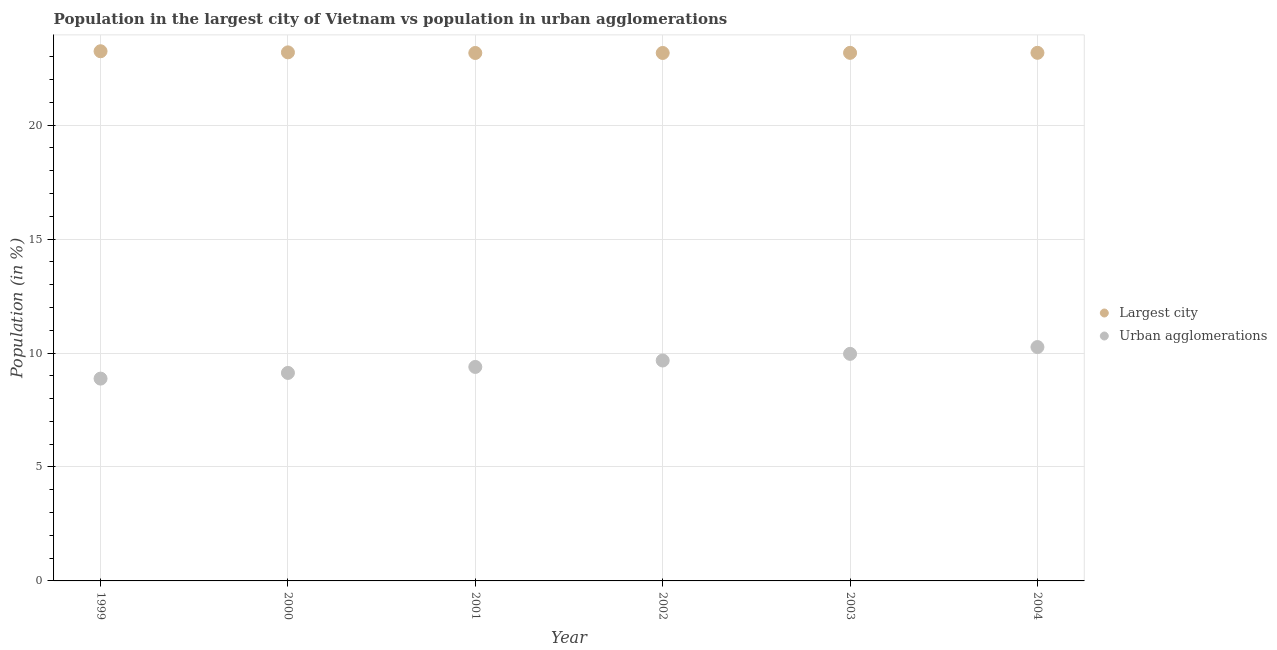How many different coloured dotlines are there?
Make the answer very short. 2. Is the number of dotlines equal to the number of legend labels?
Offer a terse response. Yes. What is the population in the largest city in 2001?
Make the answer very short. 23.17. Across all years, what is the maximum population in the largest city?
Give a very brief answer. 23.25. Across all years, what is the minimum population in urban agglomerations?
Your answer should be compact. 8.88. In which year was the population in the largest city maximum?
Make the answer very short. 1999. In which year was the population in urban agglomerations minimum?
Make the answer very short. 1999. What is the total population in urban agglomerations in the graph?
Ensure brevity in your answer.  57.3. What is the difference between the population in the largest city in 2003 and that in 2004?
Give a very brief answer. -0. What is the difference between the population in the largest city in 2001 and the population in urban agglomerations in 2000?
Keep it short and to the point. 14.04. What is the average population in urban agglomerations per year?
Ensure brevity in your answer.  9.55. In the year 1999, what is the difference between the population in the largest city and population in urban agglomerations?
Give a very brief answer. 14.37. What is the ratio of the population in urban agglomerations in 2000 to that in 2004?
Provide a short and direct response. 0.89. Is the population in urban agglomerations in 1999 less than that in 2004?
Make the answer very short. Yes. What is the difference between the highest and the second highest population in the largest city?
Your response must be concise. 0.05. What is the difference between the highest and the lowest population in urban agglomerations?
Your answer should be compact. 1.38. In how many years, is the population in the largest city greater than the average population in the largest city taken over all years?
Offer a very short reply. 2. What is the difference between two consecutive major ticks on the Y-axis?
Offer a terse response. 5. Are the values on the major ticks of Y-axis written in scientific E-notation?
Make the answer very short. No. Does the graph contain any zero values?
Your answer should be compact. No. How are the legend labels stacked?
Give a very brief answer. Vertical. What is the title of the graph?
Your answer should be compact. Population in the largest city of Vietnam vs population in urban agglomerations. Does "Frequency of shipment arrival" appear as one of the legend labels in the graph?
Keep it short and to the point. No. What is the label or title of the X-axis?
Make the answer very short. Year. What is the Population (in %) in Largest city in 1999?
Keep it short and to the point. 23.25. What is the Population (in %) of Urban agglomerations in 1999?
Your response must be concise. 8.88. What is the Population (in %) of Largest city in 2000?
Make the answer very short. 23.2. What is the Population (in %) of Urban agglomerations in 2000?
Make the answer very short. 9.13. What is the Population (in %) of Largest city in 2001?
Your answer should be very brief. 23.17. What is the Population (in %) in Urban agglomerations in 2001?
Your response must be concise. 9.39. What is the Population (in %) in Largest city in 2002?
Offer a very short reply. 23.17. What is the Population (in %) of Urban agglomerations in 2002?
Your answer should be very brief. 9.67. What is the Population (in %) in Largest city in 2003?
Your response must be concise. 23.18. What is the Population (in %) of Urban agglomerations in 2003?
Provide a short and direct response. 9.97. What is the Population (in %) of Largest city in 2004?
Ensure brevity in your answer.  23.18. What is the Population (in %) in Urban agglomerations in 2004?
Your answer should be very brief. 10.26. Across all years, what is the maximum Population (in %) in Largest city?
Provide a succinct answer. 23.25. Across all years, what is the maximum Population (in %) in Urban agglomerations?
Your answer should be compact. 10.26. Across all years, what is the minimum Population (in %) of Largest city?
Offer a terse response. 23.17. Across all years, what is the minimum Population (in %) in Urban agglomerations?
Give a very brief answer. 8.88. What is the total Population (in %) in Largest city in the graph?
Make the answer very short. 139.14. What is the total Population (in %) of Urban agglomerations in the graph?
Offer a very short reply. 57.3. What is the difference between the Population (in %) in Largest city in 1999 and that in 2000?
Ensure brevity in your answer.  0.05. What is the difference between the Population (in %) of Urban agglomerations in 1999 and that in 2000?
Your answer should be compact. -0.25. What is the difference between the Population (in %) in Largest city in 1999 and that in 2001?
Keep it short and to the point. 0.08. What is the difference between the Population (in %) in Urban agglomerations in 1999 and that in 2001?
Provide a succinct answer. -0.51. What is the difference between the Population (in %) in Largest city in 1999 and that in 2002?
Provide a short and direct response. 0.08. What is the difference between the Population (in %) in Urban agglomerations in 1999 and that in 2002?
Keep it short and to the point. -0.79. What is the difference between the Population (in %) of Largest city in 1999 and that in 2003?
Your answer should be very brief. 0.07. What is the difference between the Population (in %) in Urban agglomerations in 1999 and that in 2003?
Offer a terse response. -1.09. What is the difference between the Population (in %) in Largest city in 1999 and that in 2004?
Offer a very short reply. 0.07. What is the difference between the Population (in %) in Urban agglomerations in 1999 and that in 2004?
Keep it short and to the point. -1.38. What is the difference between the Population (in %) in Largest city in 2000 and that in 2001?
Ensure brevity in your answer.  0.03. What is the difference between the Population (in %) in Urban agglomerations in 2000 and that in 2001?
Your response must be concise. -0.26. What is the difference between the Population (in %) of Largest city in 2000 and that in 2002?
Offer a terse response. 0.03. What is the difference between the Population (in %) in Urban agglomerations in 2000 and that in 2002?
Your answer should be compact. -0.55. What is the difference between the Population (in %) in Largest city in 2000 and that in 2003?
Make the answer very short. 0.02. What is the difference between the Population (in %) in Urban agglomerations in 2000 and that in 2003?
Make the answer very short. -0.84. What is the difference between the Population (in %) in Largest city in 2000 and that in 2004?
Make the answer very short. 0.02. What is the difference between the Population (in %) in Urban agglomerations in 2000 and that in 2004?
Your response must be concise. -1.14. What is the difference between the Population (in %) in Largest city in 2001 and that in 2002?
Provide a short and direct response. -0. What is the difference between the Population (in %) in Urban agglomerations in 2001 and that in 2002?
Provide a short and direct response. -0.28. What is the difference between the Population (in %) in Largest city in 2001 and that in 2003?
Offer a terse response. -0.01. What is the difference between the Population (in %) in Urban agglomerations in 2001 and that in 2003?
Your answer should be compact. -0.57. What is the difference between the Population (in %) in Largest city in 2001 and that in 2004?
Keep it short and to the point. -0.01. What is the difference between the Population (in %) in Urban agglomerations in 2001 and that in 2004?
Provide a succinct answer. -0.87. What is the difference between the Population (in %) in Largest city in 2002 and that in 2003?
Give a very brief answer. -0.01. What is the difference between the Population (in %) in Urban agglomerations in 2002 and that in 2003?
Your answer should be compact. -0.29. What is the difference between the Population (in %) in Largest city in 2002 and that in 2004?
Offer a terse response. -0.01. What is the difference between the Population (in %) in Urban agglomerations in 2002 and that in 2004?
Your answer should be very brief. -0.59. What is the difference between the Population (in %) in Largest city in 2003 and that in 2004?
Provide a succinct answer. -0. What is the difference between the Population (in %) in Urban agglomerations in 2003 and that in 2004?
Keep it short and to the point. -0.3. What is the difference between the Population (in %) in Largest city in 1999 and the Population (in %) in Urban agglomerations in 2000?
Your response must be concise. 14.12. What is the difference between the Population (in %) of Largest city in 1999 and the Population (in %) of Urban agglomerations in 2001?
Provide a succinct answer. 13.86. What is the difference between the Population (in %) of Largest city in 1999 and the Population (in %) of Urban agglomerations in 2002?
Make the answer very short. 13.57. What is the difference between the Population (in %) in Largest city in 1999 and the Population (in %) in Urban agglomerations in 2003?
Make the answer very short. 13.28. What is the difference between the Population (in %) of Largest city in 1999 and the Population (in %) of Urban agglomerations in 2004?
Your answer should be compact. 12.98. What is the difference between the Population (in %) in Largest city in 2000 and the Population (in %) in Urban agglomerations in 2001?
Offer a terse response. 13.81. What is the difference between the Population (in %) in Largest city in 2000 and the Population (in %) in Urban agglomerations in 2002?
Give a very brief answer. 13.52. What is the difference between the Population (in %) in Largest city in 2000 and the Population (in %) in Urban agglomerations in 2003?
Provide a succinct answer. 13.23. What is the difference between the Population (in %) in Largest city in 2000 and the Population (in %) in Urban agglomerations in 2004?
Your answer should be compact. 12.93. What is the difference between the Population (in %) in Largest city in 2001 and the Population (in %) in Urban agglomerations in 2002?
Offer a terse response. 13.5. What is the difference between the Population (in %) in Largest city in 2001 and the Population (in %) in Urban agglomerations in 2003?
Provide a succinct answer. 13.2. What is the difference between the Population (in %) of Largest city in 2001 and the Population (in %) of Urban agglomerations in 2004?
Provide a short and direct response. 12.91. What is the difference between the Population (in %) of Largest city in 2002 and the Population (in %) of Urban agglomerations in 2003?
Provide a short and direct response. 13.21. What is the difference between the Population (in %) of Largest city in 2002 and the Population (in %) of Urban agglomerations in 2004?
Give a very brief answer. 12.91. What is the difference between the Population (in %) in Largest city in 2003 and the Population (in %) in Urban agglomerations in 2004?
Give a very brief answer. 12.91. What is the average Population (in %) in Largest city per year?
Ensure brevity in your answer.  23.19. What is the average Population (in %) in Urban agglomerations per year?
Offer a very short reply. 9.55. In the year 1999, what is the difference between the Population (in %) in Largest city and Population (in %) in Urban agglomerations?
Your answer should be very brief. 14.37. In the year 2000, what is the difference between the Population (in %) of Largest city and Population (in %) of Urban agglomerations?
Keep it short and to the point. 14.07. In the year 2001, what is the difference between the Population (in %) of Largest city and Population (in %) of Urban agglomerations?
Ensure brevity in your answer.  13.78. In the year 2002, what is the difference between the Population (in %) in Largest city and Population (in %) in Urban agglomerations?
Give a very brief answer. 13.5. In the year 2003, what is the difference between the Population (in %) in Largest city and Population (in %) in Urban agglomerations?
Give a very brief answer. 13.21. In the year 2004, what is the difference between the Population (in %) of Largest city and Population (in %) of Urban agglomerations?
Your answer should be very brief. 12.91. What is the ratio of the Population (in %) of Largest city in 1999 to that in 2000?
Provide a succinct answer. 1. What is the ratio of the Population (in %) of Urban agglomerations in 1999 to that in 2000?
Your response must be concise. 0.97. What is the ratio of the Population (in %) of Largest city in 1999 to that in 2001?
Provide a succinct answer. 1. What is the ratio of the Population (in %) of Urban agglomerations in 1999 to that in 2001?
Give a very brief answer. 0.95. What is the ratio of the Population (in %) of Urban agglomerations in 1999 to that in 2002?
Give a very brief answer. 0.92. What is the ratio of the Population (in %) of Largest city in 1999 to that in 2003?
Ensure brevity in your answer.  1. What is the ratio of the Population (in %) in Urban agglomerations in 1999 to that in 2003?
Ensure brevity in your answer.  0.89. What is the ratio of the Population (in %) in Urban agglomerations in 1999 to that in 2004?
Make the answer very short. 0.87. What is the ratio of the Population (in %) in Urban agglomerations in 2000 to that in 2001?
Give a very brief answer. 0.97. What is the ratio of the Population (in %) of Largest city in 2000 to that in 2002?
Keep it short and to the point. 1. What is the ratio of the Population (in %) in Urban agglomerations in 2000 to that in 2002?
Provide a short and direct response. 0.94. What is the ratio of the Population (in %) of Urban agglomerations in 2000 to that in 2003?
Provide a short and direct response. 0.92. What is the ratio of the Population (in %) in Urban agglomerations in 2000 to that in 2004?
Your response must be concise. 0.89. What is the ratio of the Population (in %) of Largest city in 2001 to that in 2002?
Your answer should be compact. 1. What is the ratio of the Population (in %) in Urban agglomerations in 2001 to that in 2002?
Offer a very short reply. 0.97. What is the ratio of the Population (in %) in Urban agglomerations in 2001 to that in 2003?
Your answer should be very brief. 0.94. What is the ratio of the Population (in %) in Urban agglomerations in 2001 to that in 2004?
Provide a succinct answer. 0.92. What is the ratio of the Population (in %) of Urban agglomerations in 2002 to that in 2003?
Keep it short and to the point. 0.97. What is the ratio of the Population (in %) of Largest city in 2002 to that in 2004?
Your answer should be very brief. 1. What is the ratio of the Population (in %) in Urban agglomerations in 2002 to that in 2004?
Your response must be concise. 0.94. What is the ratio of the Population (in %) in Largest city in 2003 to that in 2004?
Provide a short and direct response. 1. What is the ratio of the Population (in %) of Urban agglomerations in 2003 to that in 2004?
Give a very brief answer. 0.97. What is the difference between the highest and the second highest Population (in %) of Largest city?
Offer a very short reply. 0.05. What is the difference between the highest and the second highest Population (in %) in Urban agglomerations?
Give a very brief answer. 0.3. What is the difference between the highest and the lowest Population (in %) of Largest city?
Offer a terse response. 0.08. What is the difference between the highest and the lowest Population (in %) in Urban agglomerations?
Offer a terse response. 1.38. 